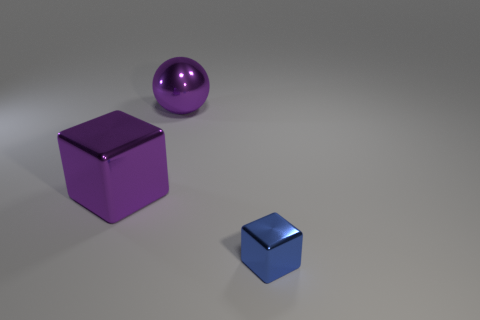What is the color of the object that is to the right of the purple shiny block and in front of the big shiny sphere?
Your answer should be very brief. Blue. Are there more things than big spheres?
Provide a succinct answer. Yes. What number of things are large cyan metallic cylinders or big purple shiny objects right of the big purple shiny cube?
Offer a very short reply. 1. Does the purple metal ball have the same size as the blue block?
Provide a succinct answer. No. There is a blue shiny cube; are there any tiny blue metallic objects on the right side of it?
Your response must be concise. No. There is a thing that is both behind the small block and to the right of the purple shiny block; how big is it?
Offer a very short reply. Large. What number of objects are blue shiny objects or big gray cylinders?
Keep it short and to the point. 1. Do the ball and the thing in front of the large block have the same size?
Provide a succinct answer. No. There is a metal block to the left of the block to the right of the shiny cube that is behind the tiny blue block; what is its size?
Your answer should be compact. Large. Are there any objects?
Make the answer very short. Yes. 